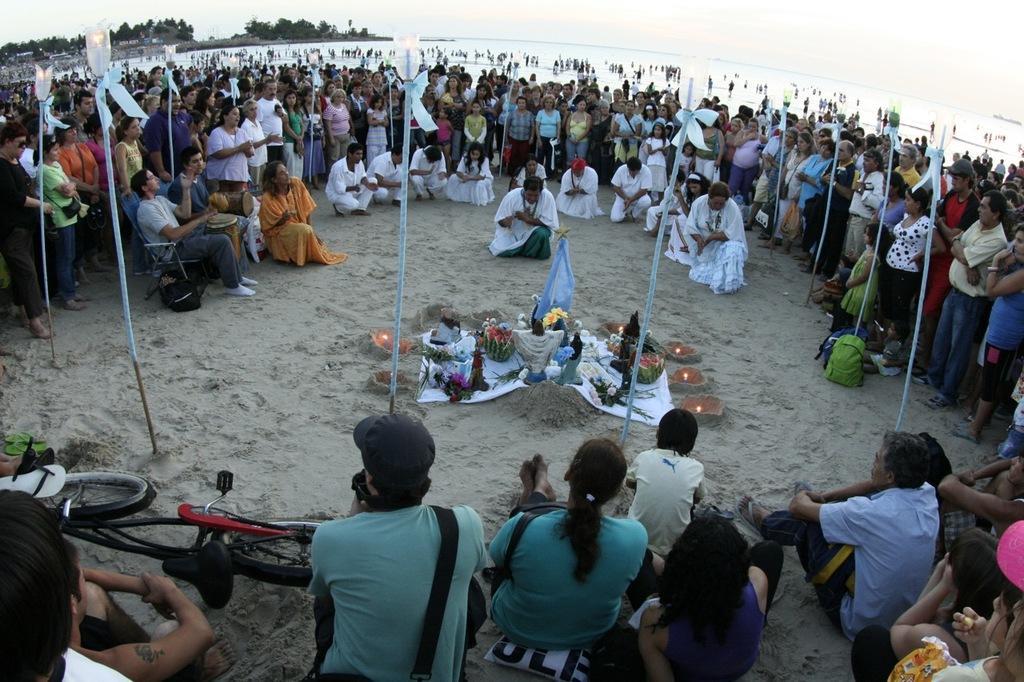Can you describe this image briefly? There are people. We can see bicycle, foot wear, light poles and objects on sand. In the background we can see water, people, trees and sky. 